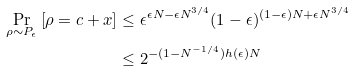Convert formula to latex. <formula><loc_0><loc_0><loc_500><loc_500>\Pr _ { \rho \sim P _ { \epsilon } } \left [ \rho = c + x \right ] & \leq \epsilon ^ { \epsilon N - \epsilon N ^ { 3 / 4 } } ( 1 - \epsilon ) ^ { ( 1 - \epsilon ) N + \epsilon N ^ { 3 / 4 } } \\ & \leq 2 ^ { - ( 1 - N ^ { - 1 / 4 } ) h ( \epsilon ) N }</formula> 